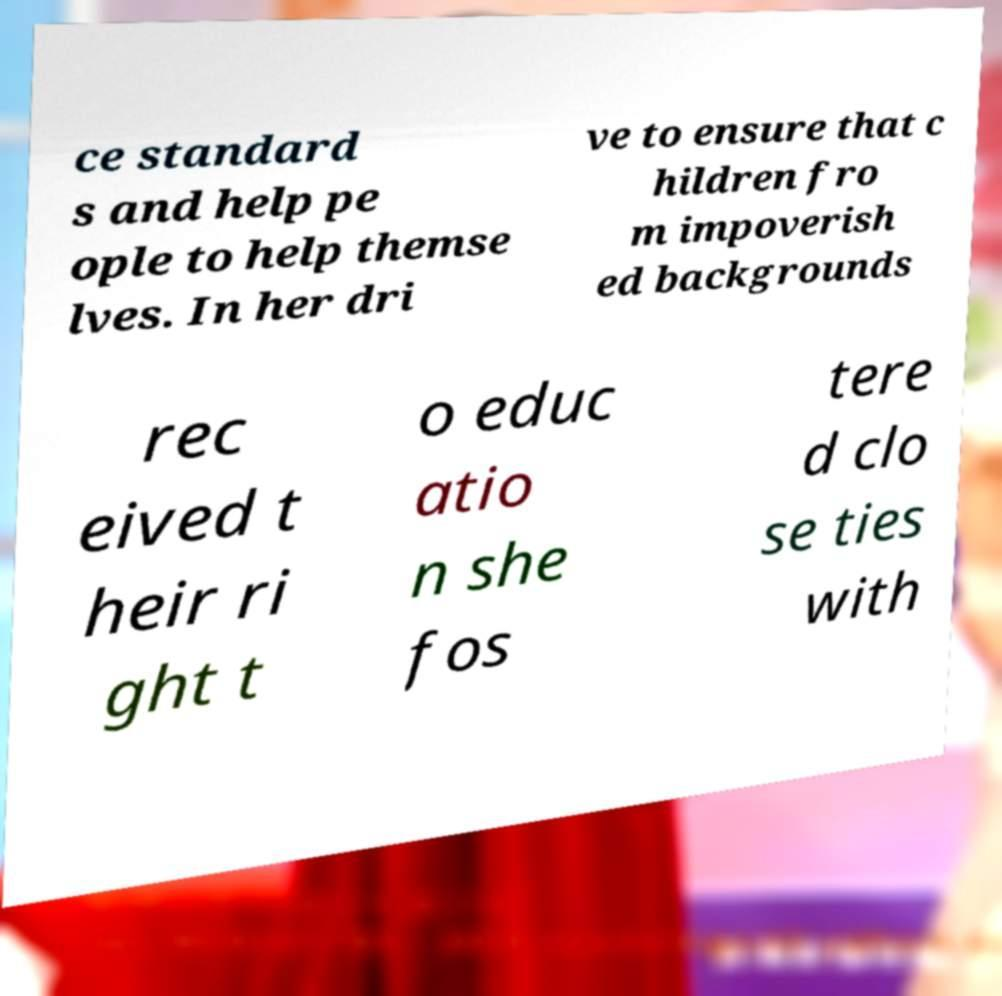For documentation purposes, I need the text within this image transcribed. Could you provide that? ce standard s and help pe ople to help themse lves. In her dri ve to ensure that c hildren fro m impoverish ed backgrounds rec eived t heir ri ght t o educ atio n she fos tere d clo se ties with 